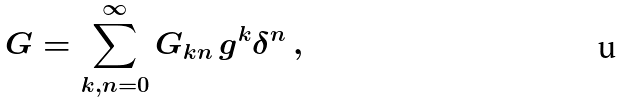<formula> <loc_0><loc_0><loc_500><loc_500>G = \sum _ { k , n = 0 } ^ { \infty } G _ { k n } \, g ^ { k } { \delta } ^ { n } \, ,</formula> 